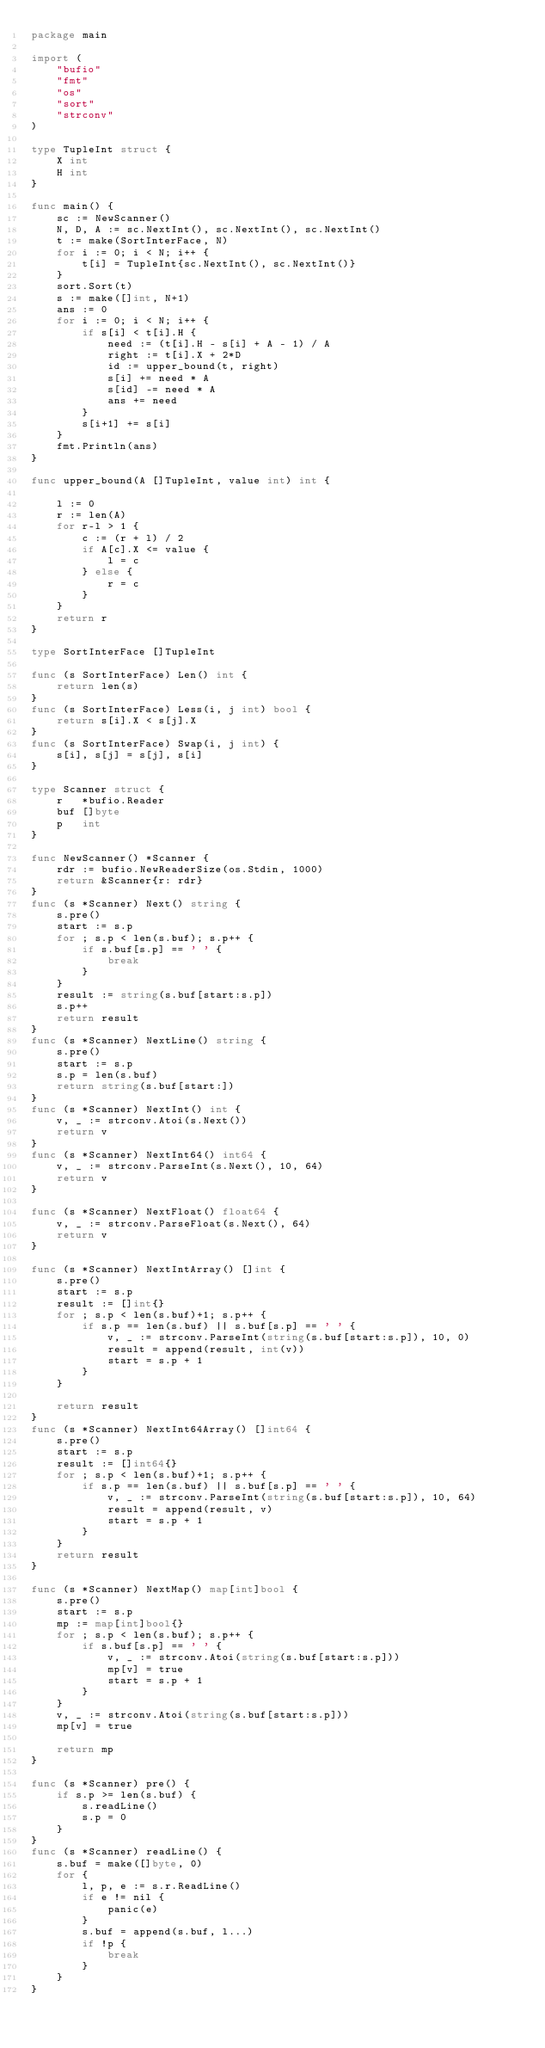<code> <loc_0><loc_0><loc_500><loc_500><_Go_>package main

import (
	"bufio"
	"fmt"
	"os"
	"sort"
	"strconv"
)

type TupleInt struct {
	X int
	H int
}

func main() {
	sc := NewScanner()
	N, D, A := sc.NextInt(), sc.NextInt(), sc.NextInt()
	t := make(SortInterFace, N)
	for i := 0; i < N; i++ {
		t[i] = TupleInt{sc.NextInt(), sc.NextInt()}
	}
	sort.Sort(t)
	s := make([]int, N+1)
	ans := 0
	for i := 0; i < N; i++ {
		if s[i] < t[i].H {
			need := (t[i].H - s[i] + A - 1) / A
			right := t[i].X + 2*D
			id := upper_bound(t, right)
			s[i] += need * A
			s[id] -= need * A
			ans += need
		}
		s[i+1] += s[i]
	}
	fmt.Println(ans)
}

func upper_bound(A []TupleInt, value int) int {

	l := 0
	r := len(A)
	for r-l > 1 {
		c := (r + l) / 2
		if A[c].X <= value {
			l = c
		} else {
			r = c
		}
	}
	return r
}

type SortInterFace []TupleInt

func (s SortInterFace) Len() int {
	return len(s)
}
func (s SortInterFace) Less(i, j int) bool {
	return s[i].X < s[j].X
}
func (s SortInterFace) Swap(i, j int) {
	s[i], s[j] = s[j], s[i]
}

type Scanner struct {
	r   *bufio.Reader
	buf []byte
	p   int
}

func NewScanner() *Scanner {
	rdr := bufio.NewReaderSize(os.Stdin, 1000)
	return &Scanner{r: rdr}
}
func (s *Scanner) Next() string {
	s.pre()
	start := s.p
	for ; s.p < len(s.buf); s.p++ {
		if s.buf[s.p] == ' ' {
			break
		}
	}
	result := string(s.buf[start:s.p])
	s.p++
	return result
}
func (s *Scanner) NextLine() string {
	s.pre()
	start := s.p
	s.p = len(s.buf)
	return string(s.buf[start:])
}
func (s *Scanner) NextInt() int {
	v, _ := strconv.Atoi(s.Next())
	return v
}
func (s *Scanner) NextInt64() int64 {
	v, _ := strconv.ParseInt(s.Next(), 10, 64)
	return v
}

func (s *Scanner) NextFloat() float64 {
	v, _ := strconv.ParseFloat(s.Next(), 64)
	return v
}

func (s *Scanner) NextIntArray() []int {
	s.pre()
	start := s.p
	result := []int{}
	for ; s.p < len(s.buf)+1; s.p++ {
		if s.p == len(s.buf) || s.buf[s.p] == ' ' {
			v, _ := strconv.ParseInt(string(s.buf[start:s.p]), 10, 0)
			result = append(result, int(v))
			start = s.p + 1
		}
	}

	return result
}
func (s *Scanner) NextInt64Array() []int64 {
	s.pre()
	start := s.p
	result := []int64{}
	for ; s.p < len(s.buf)+1; s.p++ {
		if s.p == len(s.buf) || s.buf[s.p] == ' ' {
			v, _ := strconv.ParseInt(string(s.buf[start:s.p]), 10, 64)
			result = append(result, v)
			start = s.p + 1
		}
	}
	return result
}

func (s *Scanner) NextMap() map[int]bool {
	s.pre()
	start := s.p
	mp := map[int]bool{}
	for ; s.p < len(s.buf); s.p++ {
		if s.buf[s.p] == ' ' {
			v, _ := strconv.Atoi(string(s.buf[start:s.p]))
			mp[v] = true
			start = s.p + 1
		}
	}
	v, _ := strconv.Atoi(string(s.buf[start:s.p]))
	mp[v] = true

	return mp
}

func (s *Scanner) pre() {
	if s.p >= len(s.buf) {
		s.readLine()
		s.p = 0
	}
}
func (s *Scanner) readLine() {
	s.buf = make([]byte, 0)
	for {
		l, p, e := s.r.ReadLine()
		if e != nil {
			panic(e)
		}
		s.buf = append(s.buf, l...)
		if !p {
			break
		}
	}
}
</code> 